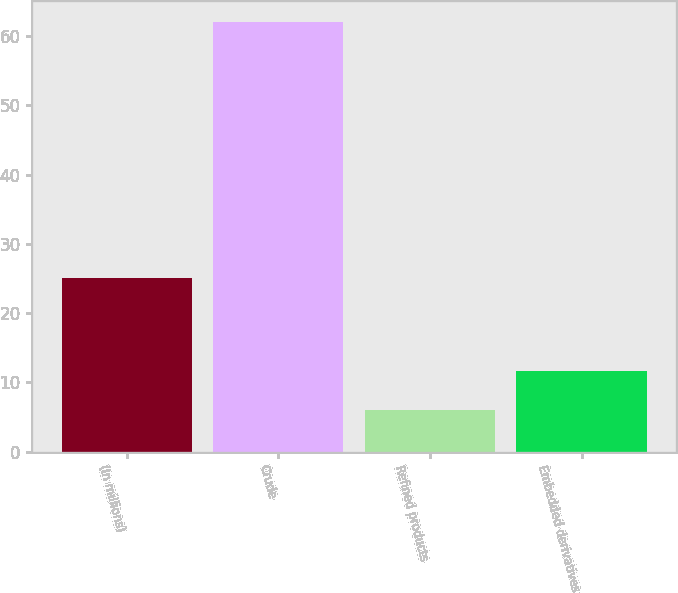<chart> <loc_0><loc_0><loc_500><loc_500><bar_chart><fcel>(In millions)<fcel>Crude<fcel>Refined products<fcel>Embedded derivatives<nl><fcel>25<fcel>62<fcel>6<fcel>11.6<nl></chart> 